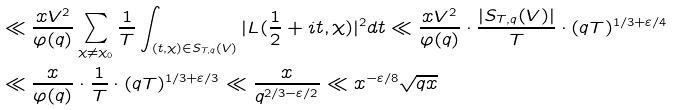<formula> <loc_0><loc_0><loc_500><loc_500>& \ll \frac { x V ^ { 2 } } { \varphi ( q ) } \sum _ { \chi \neq \chi _ { 0 } } \frac { 1 } { T } \int _ { ( t , \chi ) \in S _ { T , q } ( V ) } | L ( \frac { 1 } { 2 } + i t , \chi ) | ^ { 2 } d t \ll \frac { x V ^ { 2 } } { \varphi ( q ) } \cdot \frac { | S _ { T , q } ( V ) | } { T } \cdot ( q T ) ^ { 1 / 3 + \varepsilon / 4 } \\ & \ll \frac { x } { \varphi ( q ) } \cdot \frac { 1 } { T } \cdot ( q T ) ^ { 1 / 3 + \varepsilon / 3 } \ll \frac { x } { q ^ { 2 / 3 - \varepsilon / 2 } } \ll x ^ { - \varepsilon / 8 } \sqrt { q x }</formula> 